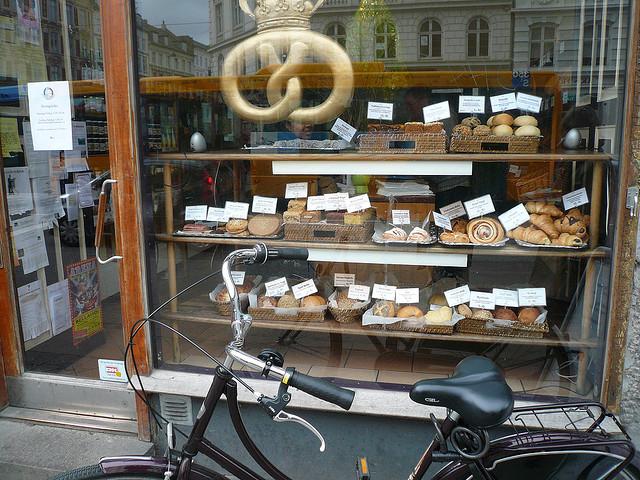How many price tags are on the top shelf?
Concise answer only. 6. What type of shop is this?
Write a very short answer. Bakery. How many wheels does the bike have?
Write a very short answer. 2. 